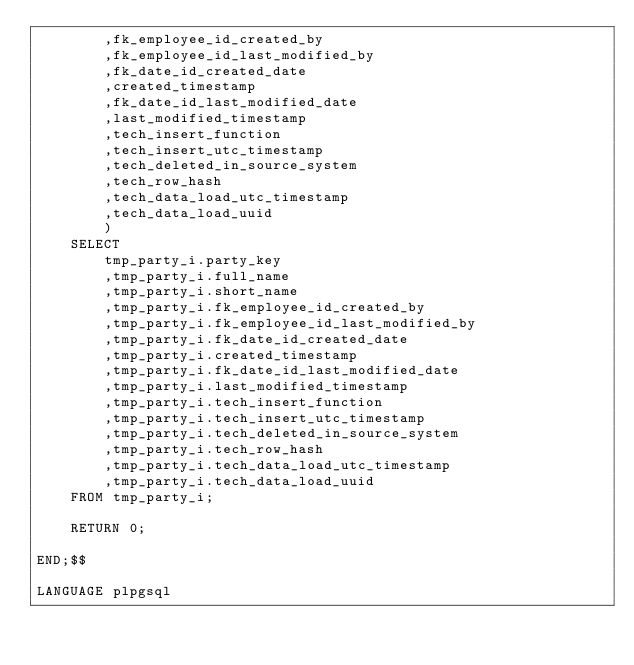Convert code to text. <code><loc_0><loc_0><loc_500><loc_500><_SQL_>        ,fk_employee_id_created_by
        ,fk_employee_id_last_modified_by
        ,fk_date_id_created_date
        ,created_timestamp
        ,fk_date_id_last_modified_date
        ,last_modified_timestamp
        ,tech_insert_function
        ,tech_insert_utc_timestamp
        ,tech_deleted_in_source_system
        ,tech_row_hash
        ,tech_data_load_utc_timestamp
        ,tech_data_load_uuid
        )
    SELECT
        tmp_party_i.party_key
        ,tmp_party_i.full_name
        ,tmp_party_i.short_name
        ,tmp_party_i.fk_employee_id_created_by
        ,tmp_party_i.fk_employee_id_last_modified_by
        ,tmp_party_i.fk_date_id_created_date
        ,tmp_party_i.created_timestamp
        ,tmp_party_i.fk_date_id_last_modified_date
        ,tmp_party_i.last_modified_timestamp
        ,tmp_party_i.tech_insert_function
        ,tmp_party_i.tech_insert_utc_timestamp
        ,tmp_party_i.tech_deleted_in_source_system
        ,tmp_party_i.tech_row_hash
        ,tmp_party_i.tech_data_load_utc_timestamp
        ,tmp_party_i.tech_data_load_uuid
    FROM tmp_party_i;

    RETURN 0;

END;$$

LANGUAGE plpgsql
</code> 